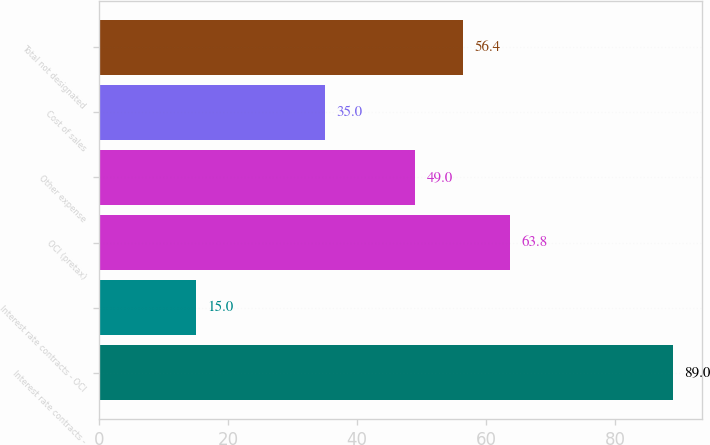<chart> <loc_0><loc_0><loc_500><loc_500><bar_chart><fcel>Interest rate contracts -<fcel>Interest rate contracts - OCI<fcel>OCI (pretax)<fcel>Other expense<fcel>Cost of sales<fcel>Total not designated<nl><fcel>89<fcel>15<fcel>63.8<fcel>49<fcel>35<fcel>56.4<nl></chart> 